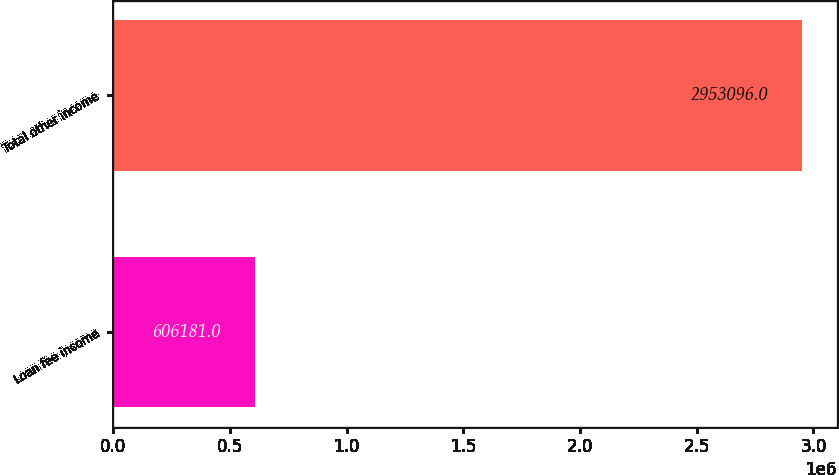<chart> <loc_0><loc_0><loc_500><loc_500><bar_chart><fcel>Loan fee income<fcel>Total other income<nl><fcel>606181<fcel>2.9531e+06<nl></chart> 